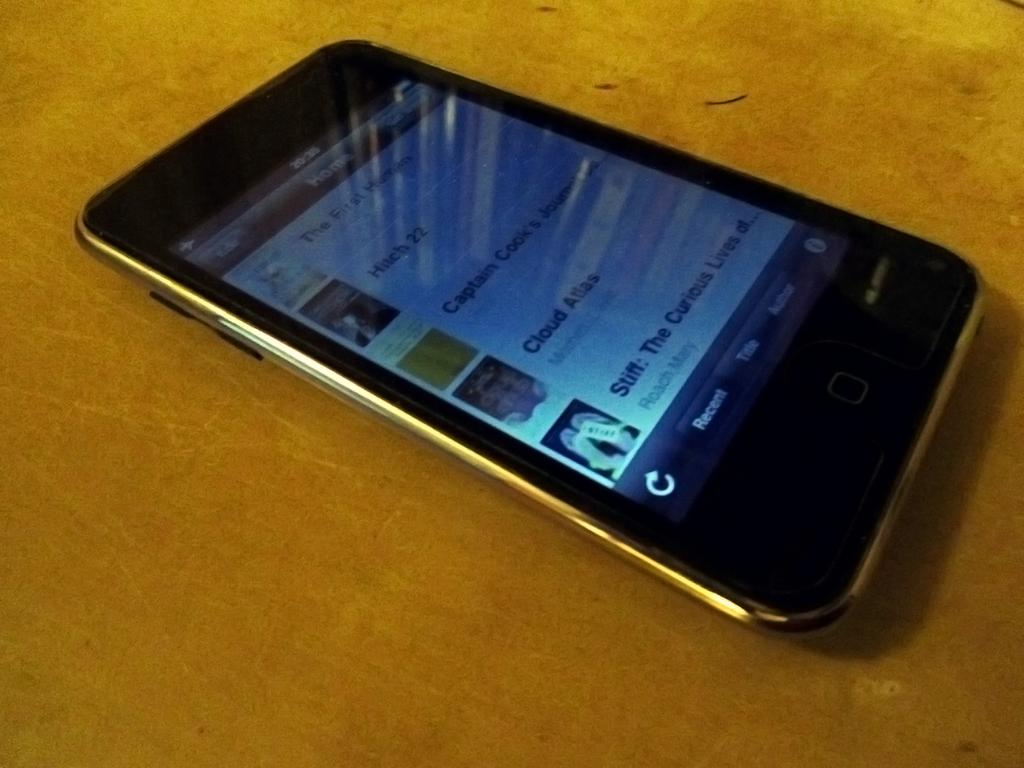<image>
Share a concise interpretation of the image provided. A phone shows its home page with options such as Cloud Atlas. 